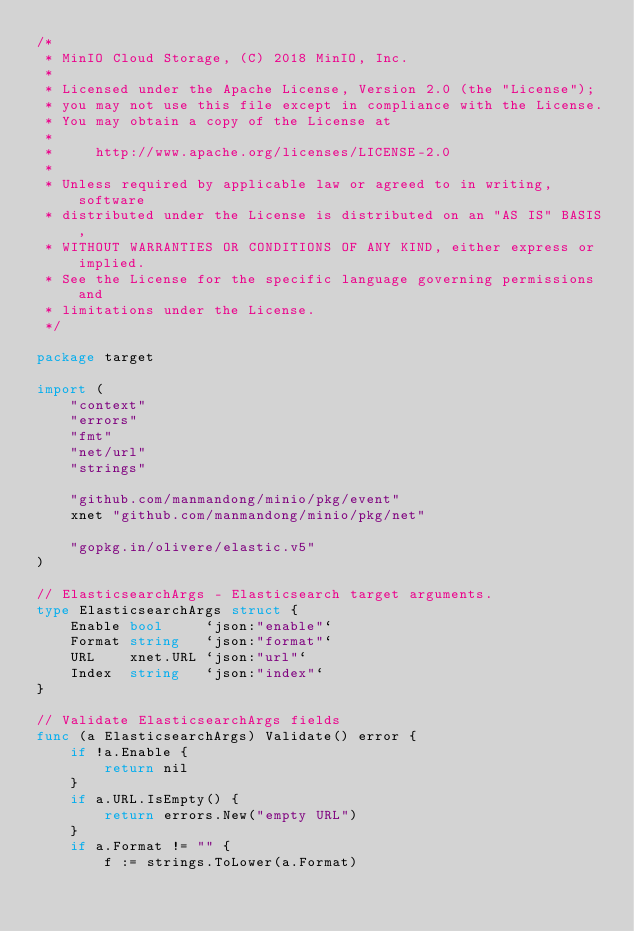Convert code to text. <code><loc_0><loc_0><loc_500><loc_500><_Go_>/*
 * MinIO Cloud Storage, (C) 2018 MinIO, Inc.
 *
 * Licensed under the Apache License, Version 2.0 (the "License");
 * you may not use this file except in compliance with the License.
 * You may obtain a copy of the License at
 *
 *     http://www.apache.org/licenses/LICENSE-2.0
 *
 * Unless required by applicable law or agreed to in writing, software
 * distributed under the License is distributed on an "AS IS" BASIS,
 * WITHOUT WARRANTIES OR CONDITIONS OF ANY KIND, either express or implied.
 * See the License for the specific language governing permissions and
 * limitations under the License.
 */

package target

import (
	"context"
	"errors"
	"fmt"
	"net/url"
	"strings"

	"github.com/manmandong/minio/pkg/event"
	xnet "github.com/manmandong/minio/pkg/net"

	"gopkg.in/olivere/elastic.v5"
)

// ElasticsearchArgs - Elasticsearch target arguments.
type ElasticsearchArgs struct {
	Enable bool     `json:"enable"`
	Format string   `json:"format"`
	URL    xnet.URL `json:"url"`
	Index  string   `json:"index"`
}

// Validate ElasticsearchArgs fields
func (a ElasticsearchArgs) Validate() error {
	if !a.Enable {
		return nil
	}
	if a.URL.IsEmpty() {
		return errors.New("empty URL")
	}
	if a.Format != "" {
		f := strings.ToLower(a.Format)</code> 